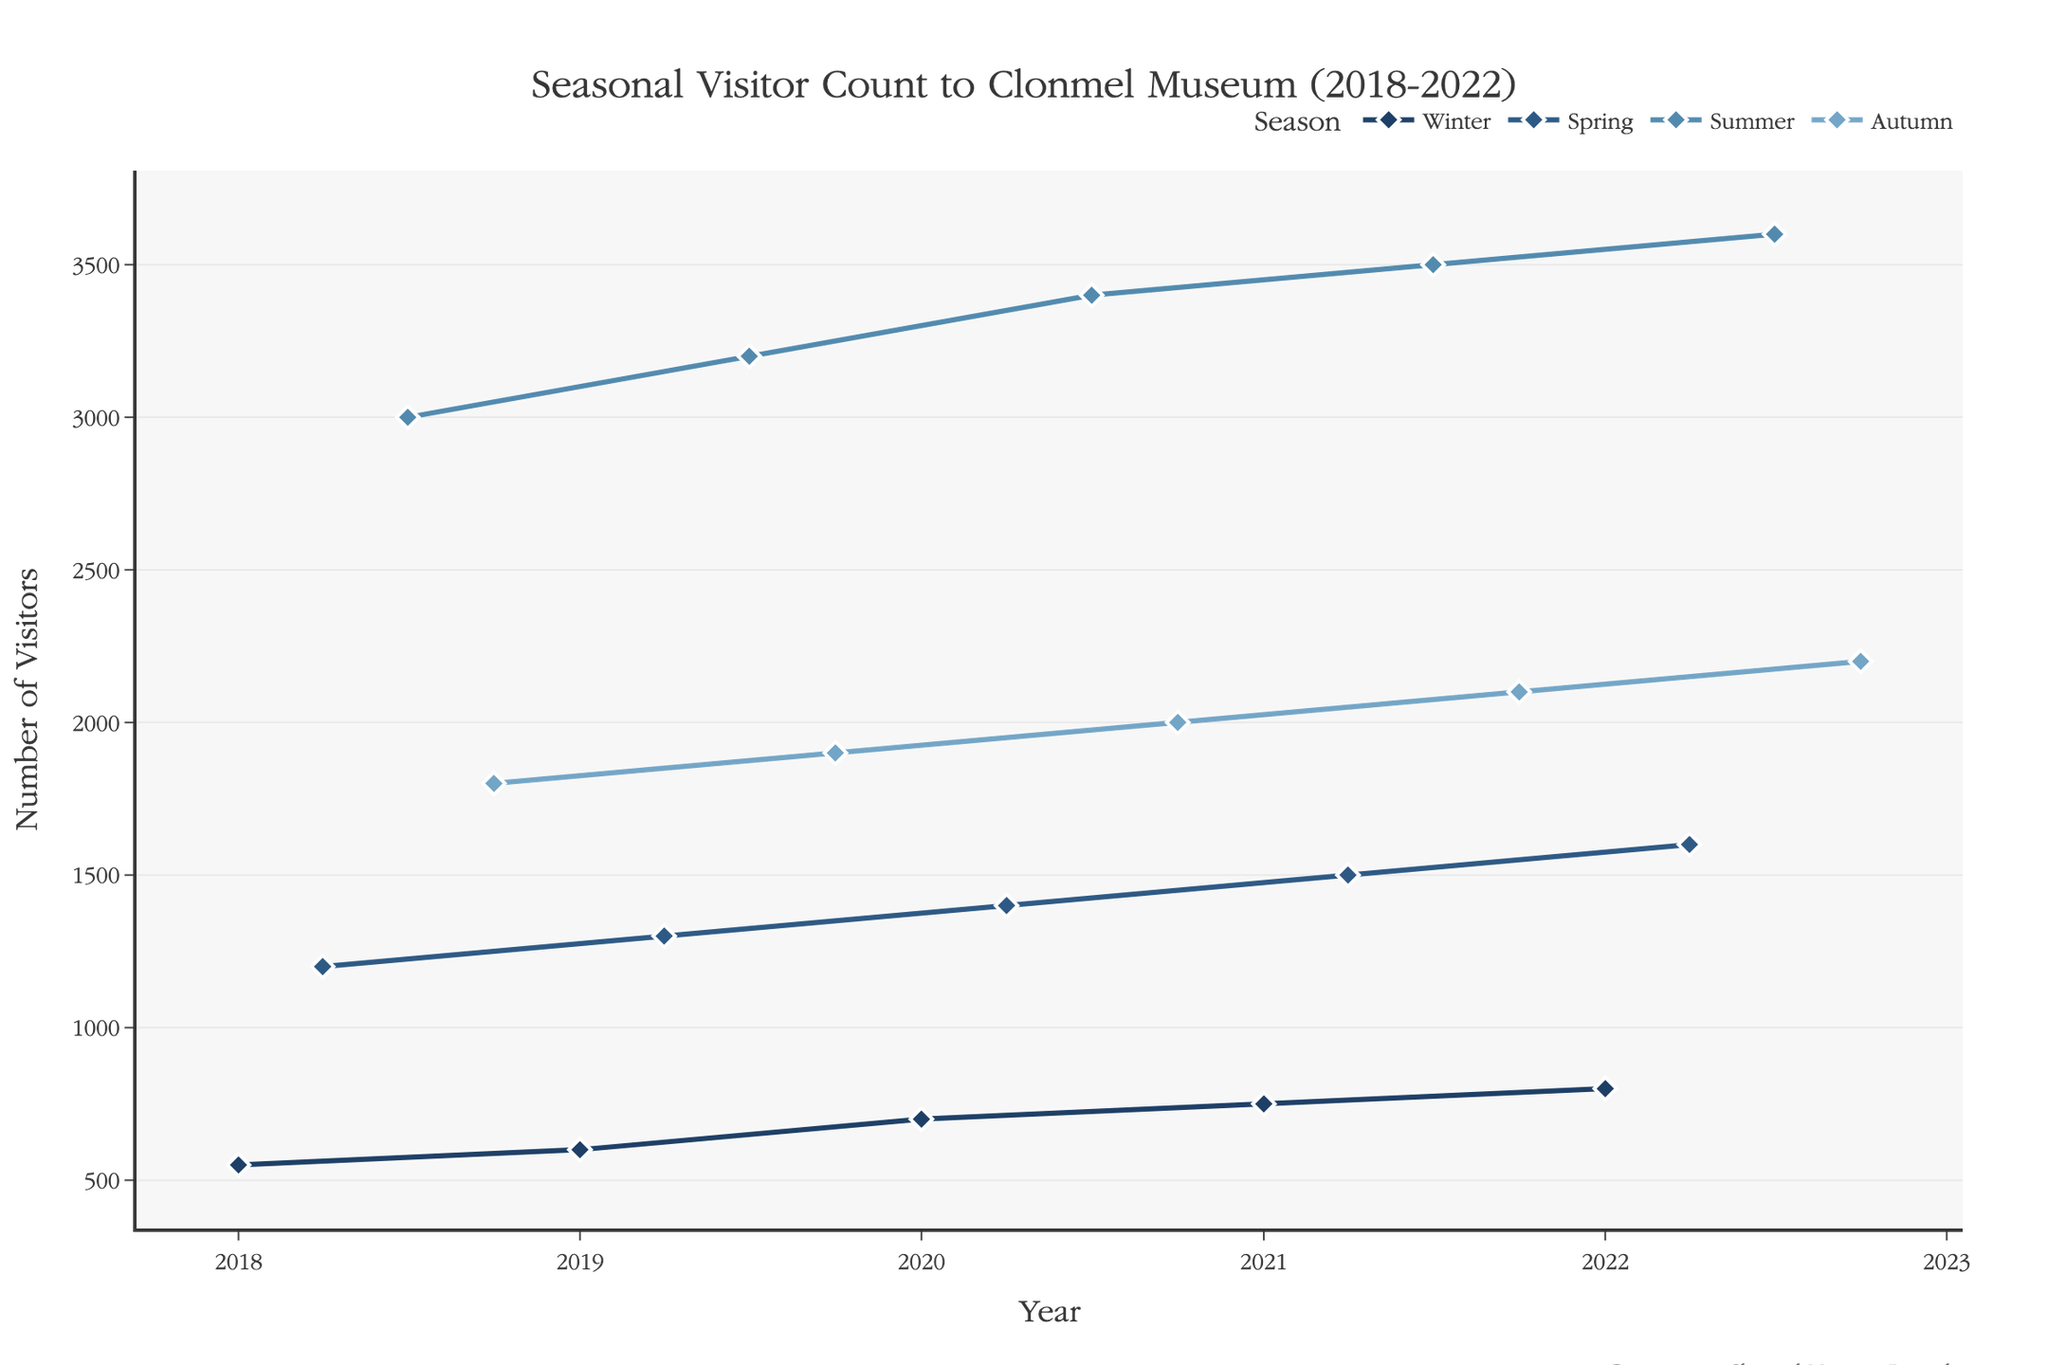What is the title of the figure? Look at the top of the figure to find the title. The title is "Seasonal Visitor Count to Clonmel Museum (2018-2022)".
Answer: Seasonal Visitor Count to Clonmel Museum (2018-2022) How many total visitors did the museum have in Summer 2019? Find the data point for Summer 2019 and read the visitor count. The chart shows that the summer visitor count is 3200.
Answer: 3200 Which season had the highest average visitor count from 2018 to 2022? Calculate the average visitor count for each season over the years. Summer: (3000+3200+3400+3500+3600)/5 = 3340; other seasons have lower averages.
Answer: Summer What was the increase in visitors from Spring to Summer in the year 2020? Subtract the Spring 2020 visitor count from the Summer 2020 visitor count: 3400 - 1400 = 2000.
Answer: 2000 Which year had the highest Autumn visitor count? Read the Autumn data points for each year and compare: 2022 had the highest with 2200 visitors.
Answer: 2022 In which season did the visitor count increase each year from 2018 to 2022? Examine the trend lines for each season. Winter shows a steady increase every year from 550 to 800.
Answer: Winter How many more visitors were there in Summer 2021 compared to Winter 2021? Subtract Winter 2021 visitors from Summer 2021 visitors: 3500 - 750 = 2750.
Answer: 2750 What is the average visitor count in Autumn from 2018 to 2022? Sum the visitor counts for Autumn across the years and divide by the number of years: (1800+1900+2000+2100+2200)/5 = 2000.
Answer: 2000 Which season saw the greatest increase in visitors between 2018 and 2022? Compare the visitor counts from 2018 to 2022 for each season. Summer increased by 600 (3600-3000).
Answer: Summer What trend can be observed in the visitor count during Winter from 2018 to 2022? The data shows a consistent year-over-year increase in visitor count during Winter.
Answer: Increasing 